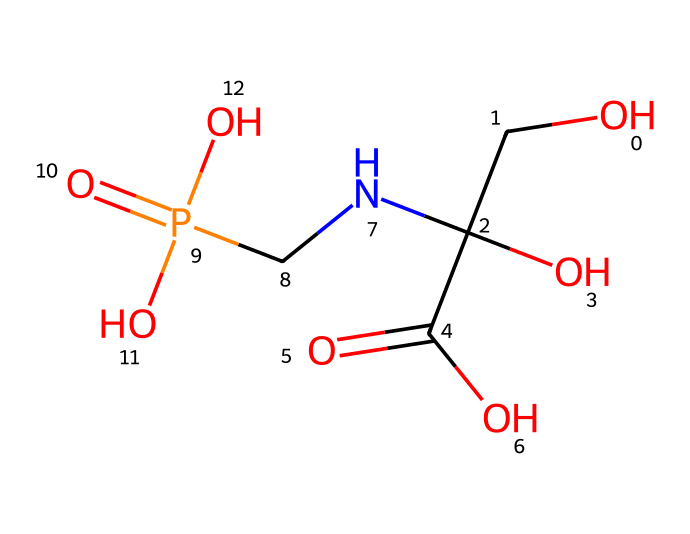What is the molecular formula of glyphosate? By analyzing the SMILES representation, we can identify the types and numbers of atoms involved in this molecule. The relevant groups in the structure indicate the presence of carbon (C), hydrogen (H), nitrogen (N), phosphorus (P), and oxygen (O). Counting these, we find that the molecular formula is C3H8N5O5P.
Answer: C3H8N5O5P How many nitrogen atoms are present in glyphosate? In the SMILES representation, we can see one nitrogen atom represented by 'N'. By counting the occurrences of nitrogen, we confirm that there is one nitrogen atom in the structure.
Answer: 1 What functional groups are present in glyphosate? By examining the structure, we can identify key functional groups such as a carboxylic acid (-COOH) and an amine (-NH). These groups are characteristic of the functional behavior in herbicides.
Answer: carboxylic acid and amine What role does glyphosate play in agriculture? Glyphosate is widely known as a non-selective herbicide used to kill weeds and grasses. Its mechanism involves inhibiting a specific enzyme pathway essential for plant growth, making it effective for managing unwanted vegetation.
Answer: herbicide How does glyphosate affect plant growth at the molecular level? Glyphosate inhibits the shikimic acid pathway, which is critical for synthesizing certain amino acids necessary for protein production in plants. This inhibition leads to the cessation of growth and eventual death of the targeted plants.
Answer: inhibits growth What is the significance of the phosphorus atom in glyphosate's structure? The presence of phosphorus in herbicides like glyphosate is crucial as it helps with the binding and interaction of the molecule with plant enzymes and contributes to the chemical's overall effectiveness in disrupting metabolic processes in plants.
Answer: important for activity 